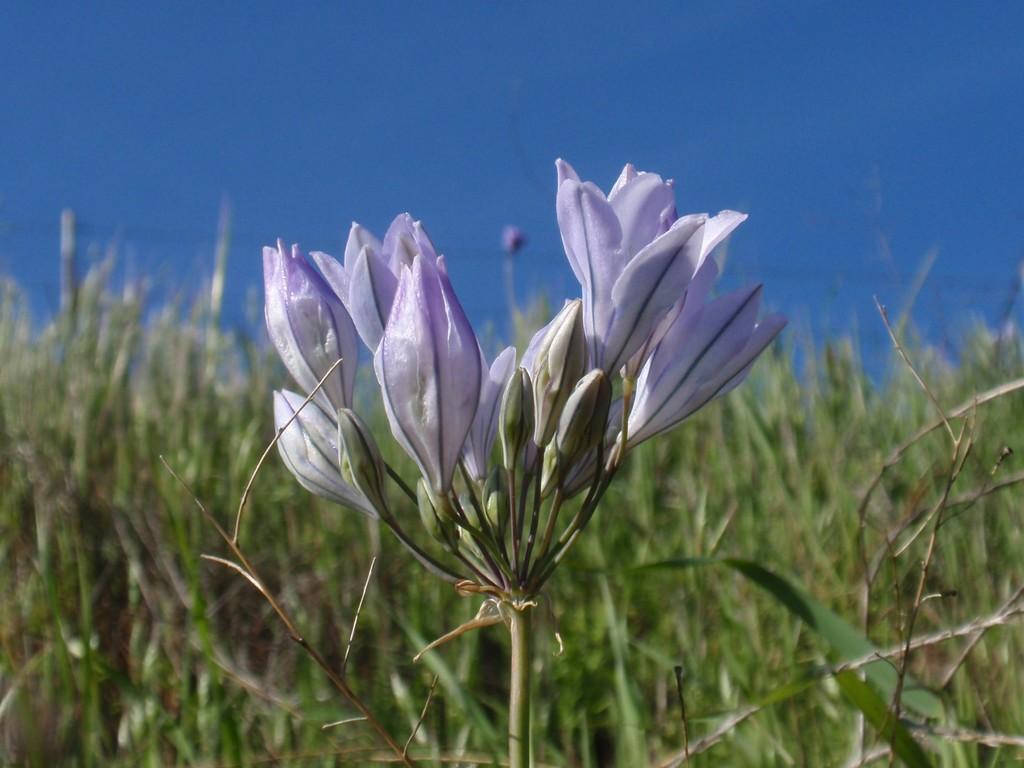Could you give a brief overview of what you see in this image? In this image, we can see flowers, flower buds and stems. Background we can see blur view. Here there are few plants and sky. 